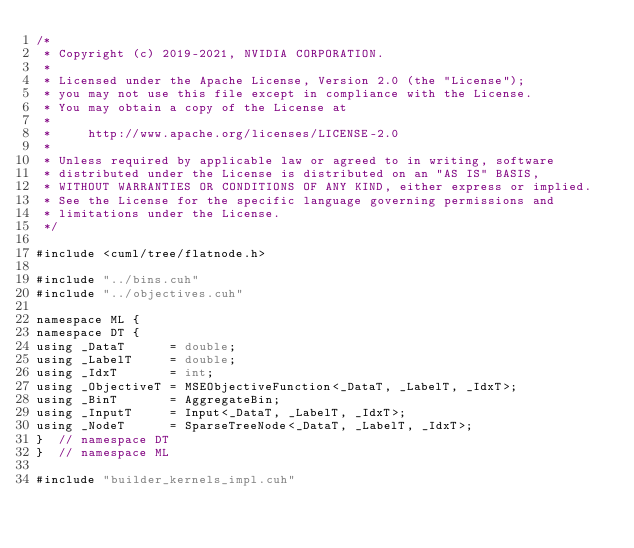Convert code to text. <code><loc_0><loc_0><loc_500><loc_500><_Cuda_>/*
 * Copyright (c) 2019-2021, NVIDIA CORPORATION.
 *
 * Licensed under the Apache License, Version 2.0 (the "License");
 * you may not use this file except in compliance with the License.
 * You may obtain a copy of the License at
 *
 *     http://www.apache.org/licenses/LICENSE-2.0
 *
 * Unless required by applicable law or agreed to in writing, software
 * distributed under the License is distributed on an "AS IS" BASIS,
 * WITHOUT WARRANTIES OR CONDITIONS OF ANY KIND, either express or implied.
 * See the License for the specific language governing permissions and
 * limitations under the License.
 */

#include <cuml/tree/flatnode.h>

#include "../bins.cuh"
#include "../objectives.cuh"

namespace ML {
namespace DT {
using _DataT      = double;
using _LabelT     = double;
using _IdxT       = int;
using _ObjectiveT = MSEObjectiveFunction<_DataT, _LabelT, _IdxT>;
using _BinT       = AggregateBin;
using _InputT     = Input<_DataT, _LabelT, _IdxT>;
using _NodeT      = SparseTreeNode<_DataT, _LabelT, _IdxT>;
}  // namespace DT
}  // namespace ML

#include "builder_kernels_impl.cuh"
</code> 